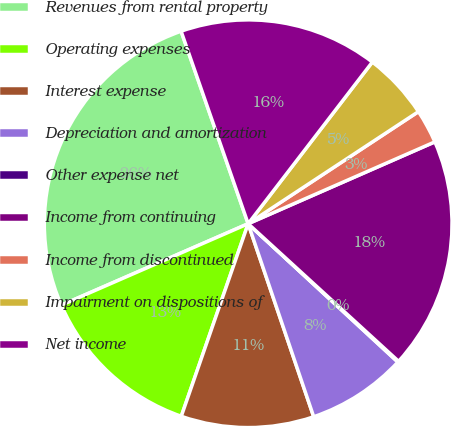Convert chart to OTSL. <chart><loc_0><loc_0><loc_500><loc_500><pie_chart><fcel>Revenues from rental property<fcel>Operating expenses<fcel>Interest expense<fcel>Depreciation and amortization<fcel>Other expense net<fcel>Income from continuing<fcel>Income from discontinued<fcel>Impairment on dispositions of<fcel>Net income<nl><fcel>26.21%<fcel>13.14%<fcel>10.53%<fcel>7.92%<fcel>0.08%<fcel>18.37%<fcel>2.69%<fcel>5.31%<fcel>15.76%<nl></chart> 